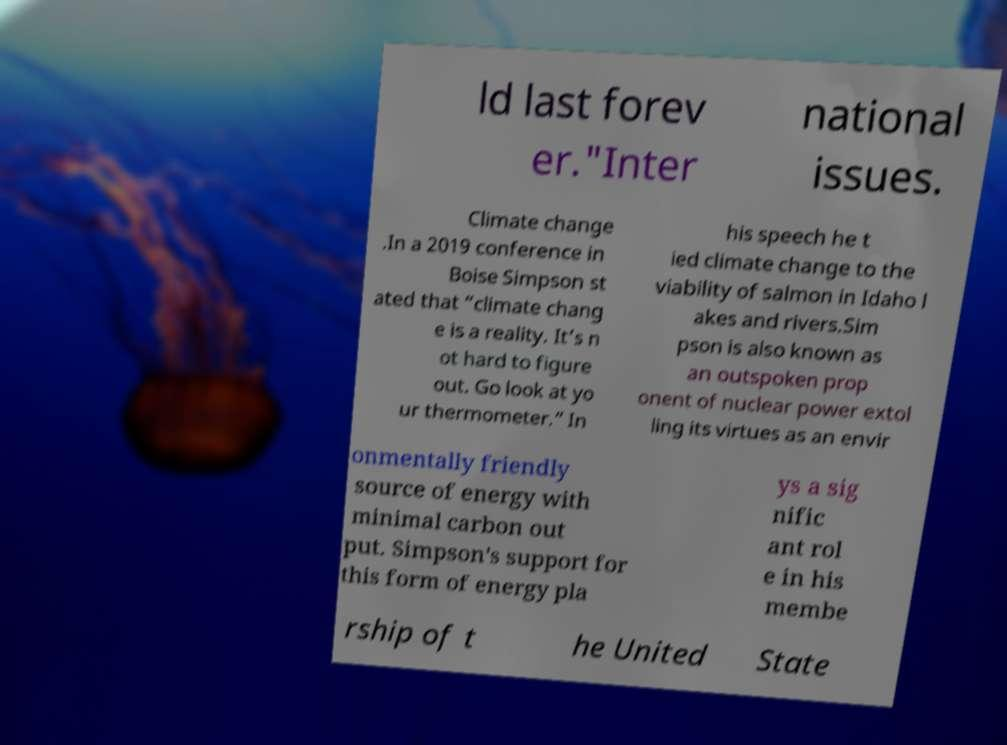What messages or text are displayed in this image? I need them in a readable, typed format. ld last forev er."Inter national issues. Climate change .In a 2019 conference in Boise Simpson st ated that “climate chang e is a reality. It’s n ot hard to figure out. Go look at yo ur thermometer.” In his speech he t ied climate change to the viability of salmon in Idaho l akes and rivers.Sim pson is also known as an outspoken prop onent of nuclear power extol ling its virtues as an envir onmentally friendly source of energy with minimal carbon out put. Simpson's support for this form of energy pla ys a sig nific ant rol e in his membe rship of t he United State 